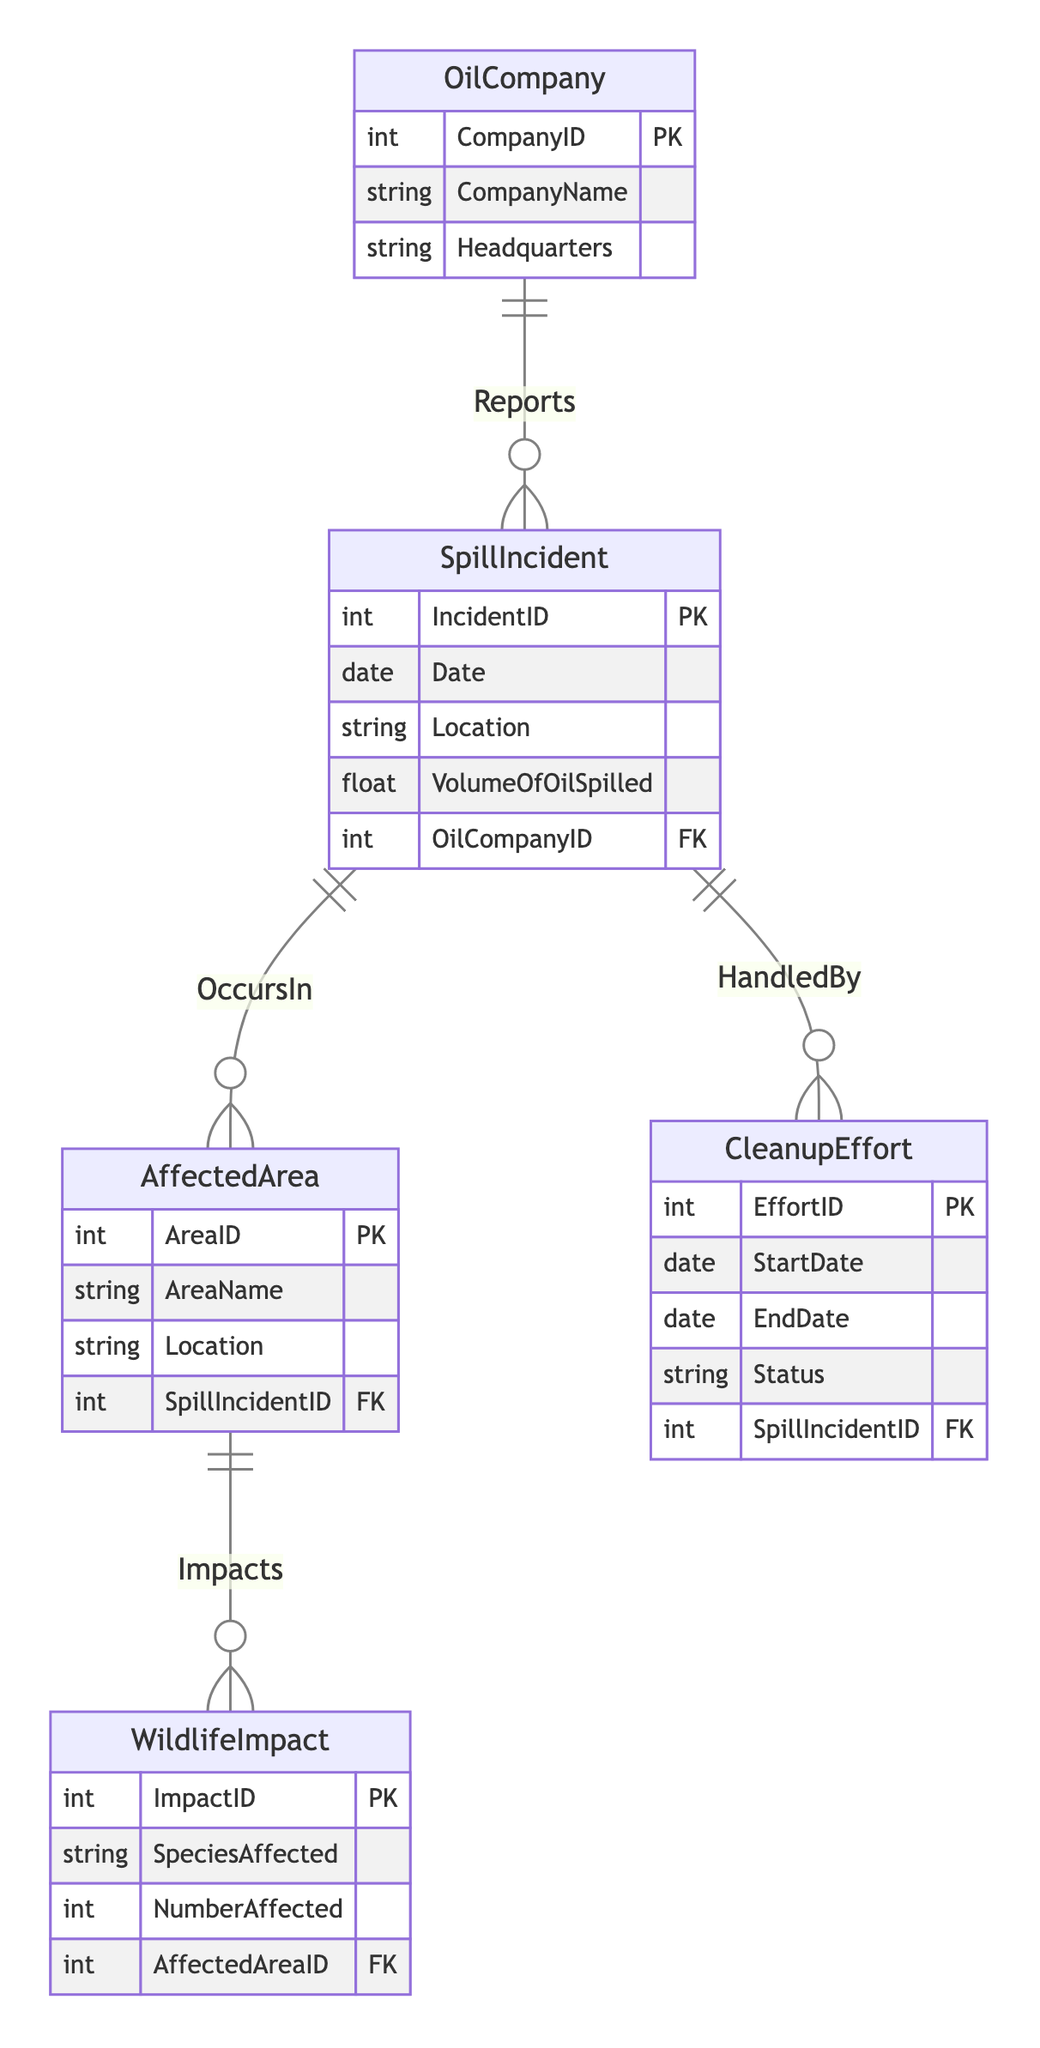What entities are included in the diagram? The diagram contains the entities: Oil Company, Spill Incident, Affected Area, Wildlife Impact, and Cleanup Effort.
Answer: Oil Company, Spill Incident, Affected Area, Wildlife Impact, Cleanup Effort How many attributes does the Spill Incident entity have? The Spill Incident entity has five attributes: IncidentID, Date, Location, VolumeOfOilSpilled, and OilCompanyID.
Answer: Five What is the relationship between Oil Company and Spill Incident? The relationship is one to many, meaning one oil company can report multiple spill incidents.
Answer: One to many Which entity is connected to Cleanup Effort? The Cleanup Effort entity is connected to the Spill Incident entity, indicating that each cleanup effort corresponds to a specific spill incident.
Answer: Spill Incident How many wildlife impacts can occur in an affected area? The relationship defines that one affected area can have multiple wildlife impacts, indicating a one to many relationship.
Answer: Many What attributes does the Wildlife Impact entity have? The Wildlife Impact entity includes the attributes: ImpactID, SpeciesAffected, NumberAffected, and AffectedAreaID.
Answer: ImpactID, SpeciesAffected, NumberAffected, AffectedAreaID What is the foreign key in the Spill Incident entity? The foreign key in the Spill Incident entity is OilCompanyID, which links the incident to the reporting oil company.
Answer: OilCompanyID Which entity represents the ecological effect of an oil spill on species? The Wildlife Impact entity represents the ecological effects on various species affected by an oil spill.
Answer: Wildlife Impact What type of relationship exists between Spill Incident and Affected Area? The relationship is one to many, indicating that each spill incident can affect multiple areas.
Answer: One to many 